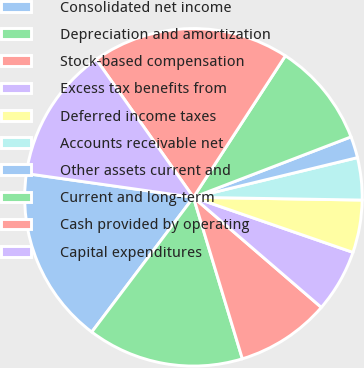Convert chart to OTSL. <chart><loc_0><loc_0><loc_500><loc_500><pie_chart><fcel>Consolidated net income<fcel>Depreciation and amortization<fcel>Stock-based compensation<fcel>Excess tax benefits from<fcel>Deferred income taxes<fcel>Accounts receivable net<fcel>Other assets current and<fcel>Current and long-term<fcel>Cash provided by operating<fcel>Capital expenditures<nl><fcel>16.96%<fcel>14.97%<fcel>9.01%<fcel>6.02%<fcel>5.03%<fcel>4.04%<fcel>2.05%<fcel>10.0%<fcel>18.95%<fcel>12.98%<nl></chart> 